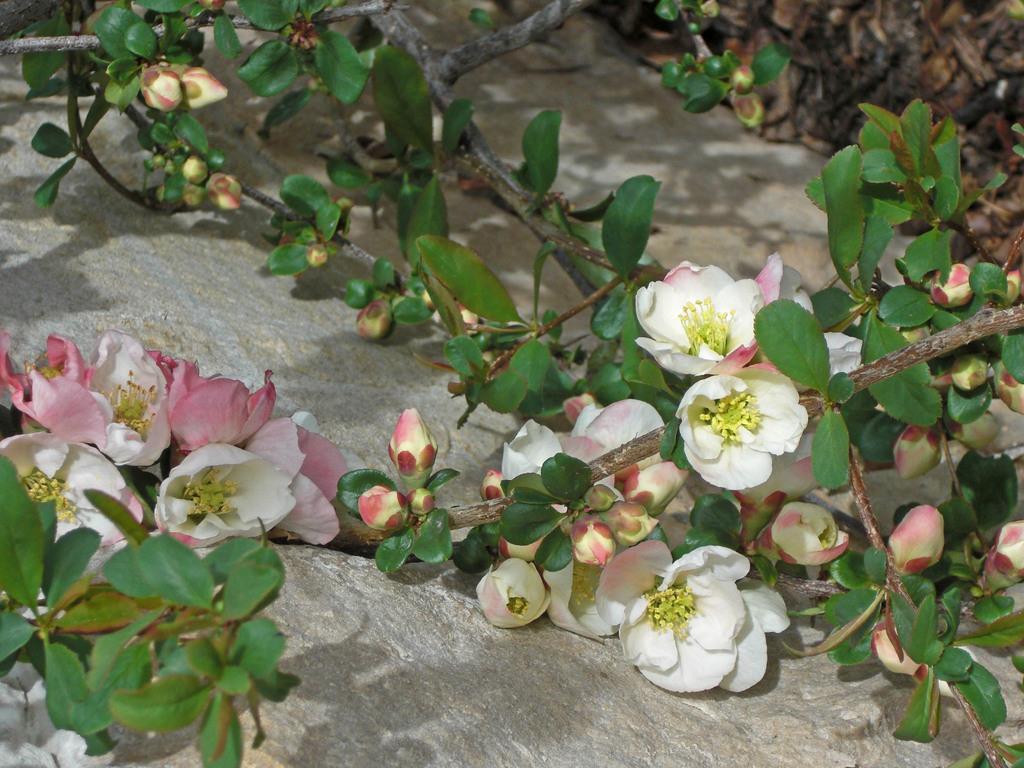Could you give a brief overview of what you see in this image? At the bottom of this image there is a rock. On the rock there are few stems along with the flowers, buds and leaves. The flowers are in white and pink colors. 